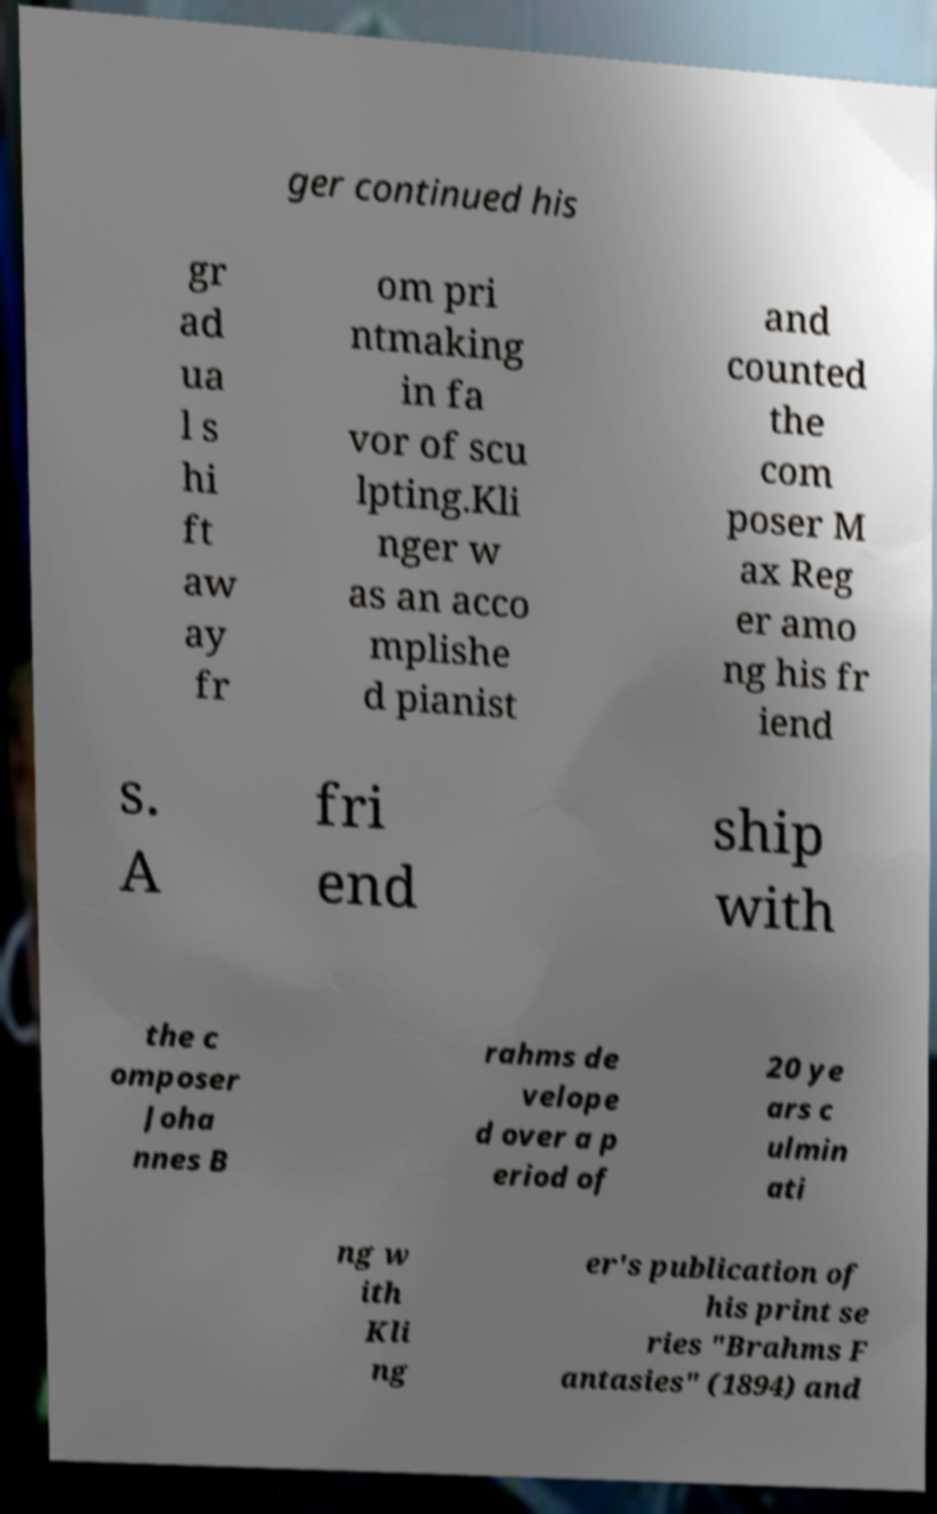Can you read and provide the text displayed in the image?This photo seems to have some interesting text. Can you extract and type it out for me? ger continued his gr ad ua l s hi ft aw ay fr om pri ntmaking in fa vor of scu lpting.Kli nger w as an acco mplishe d pianist and counted the com poser M ax Reg er amo ng his fr iend s. A fri end ship with the c omposer Joha nnes B rahms de velope d over a p eriod of 20 ye ars c ulmin ati ng w ith Kli ng er's publication of his print se ries "Brahms F antasies" (1894) and 